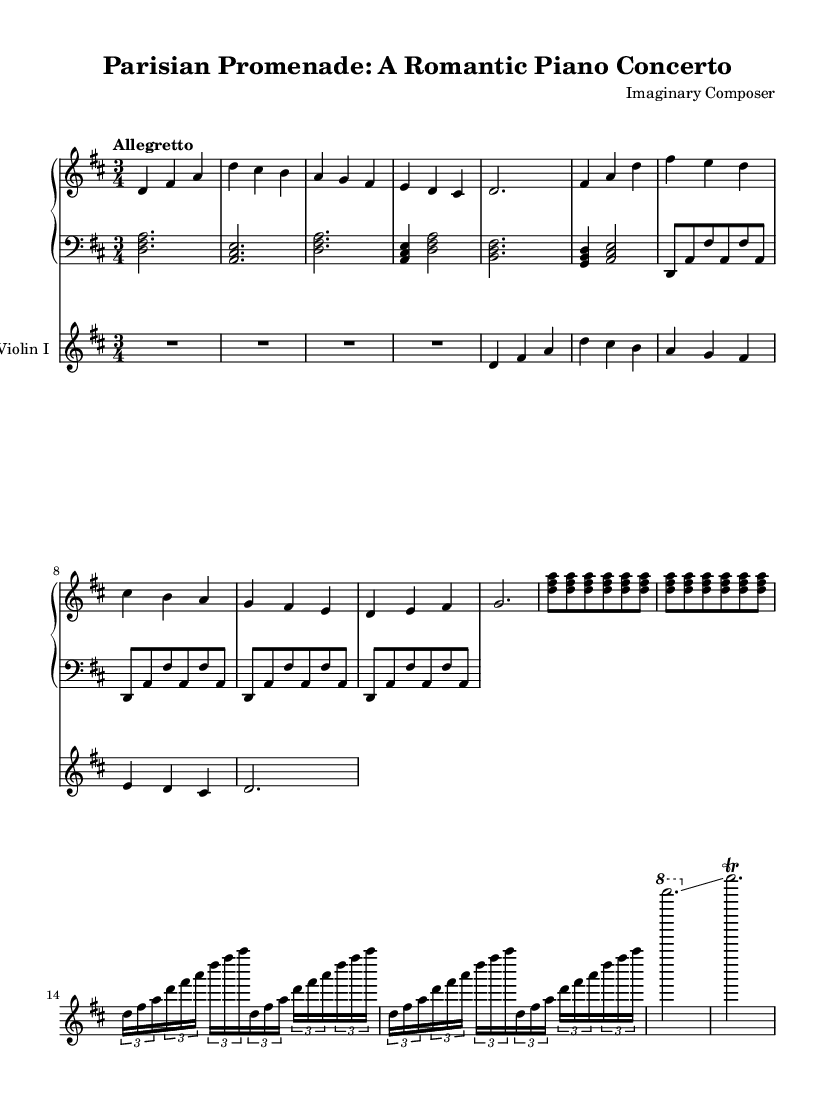What is the key signature of this music? The key signature is indicated by the sharp signs, and in this case, there are two sharps, indicating D major.
Answer: D major What is the time signature of this music? The time signature is written at the beginning and shows 3/4, which means there are three beats per measure, and each quarter note is one beat.
Answer: 3/4 What is the tempo marking for this music? The tempo marking "Allegretto" indicates the speed at which the piece should be played, and "Allegretto" generally denotes a moderately fast tempo.
Answer: Allegretto How many times is the main theme repeated in the piano part? In the score, the piano right-hand part contains a clear repeat indication for the main theme, and it is repeated two times before proceeding to the next section.
Answer: 2 What dynamic marking is present in the violin part? The violin part does not have a specific dynamic marking stated in the provided segment, hence we conclude it is defaulting to a standard piano notation.
Answer: None What is the structure of the concerto as indicated in the music? The structure includes a main theme followed by a secondary theme, then repeats, that is common in concerto form showcasing contrasting sections leading to an expressive conclusion.
Answer: Theme and Variations What is the highest note played in the concerto? Looking at the sheet music for the piano right-hand part and the violin part, the highest note appears to be indicated as the A at the third octave.
Answer: A 